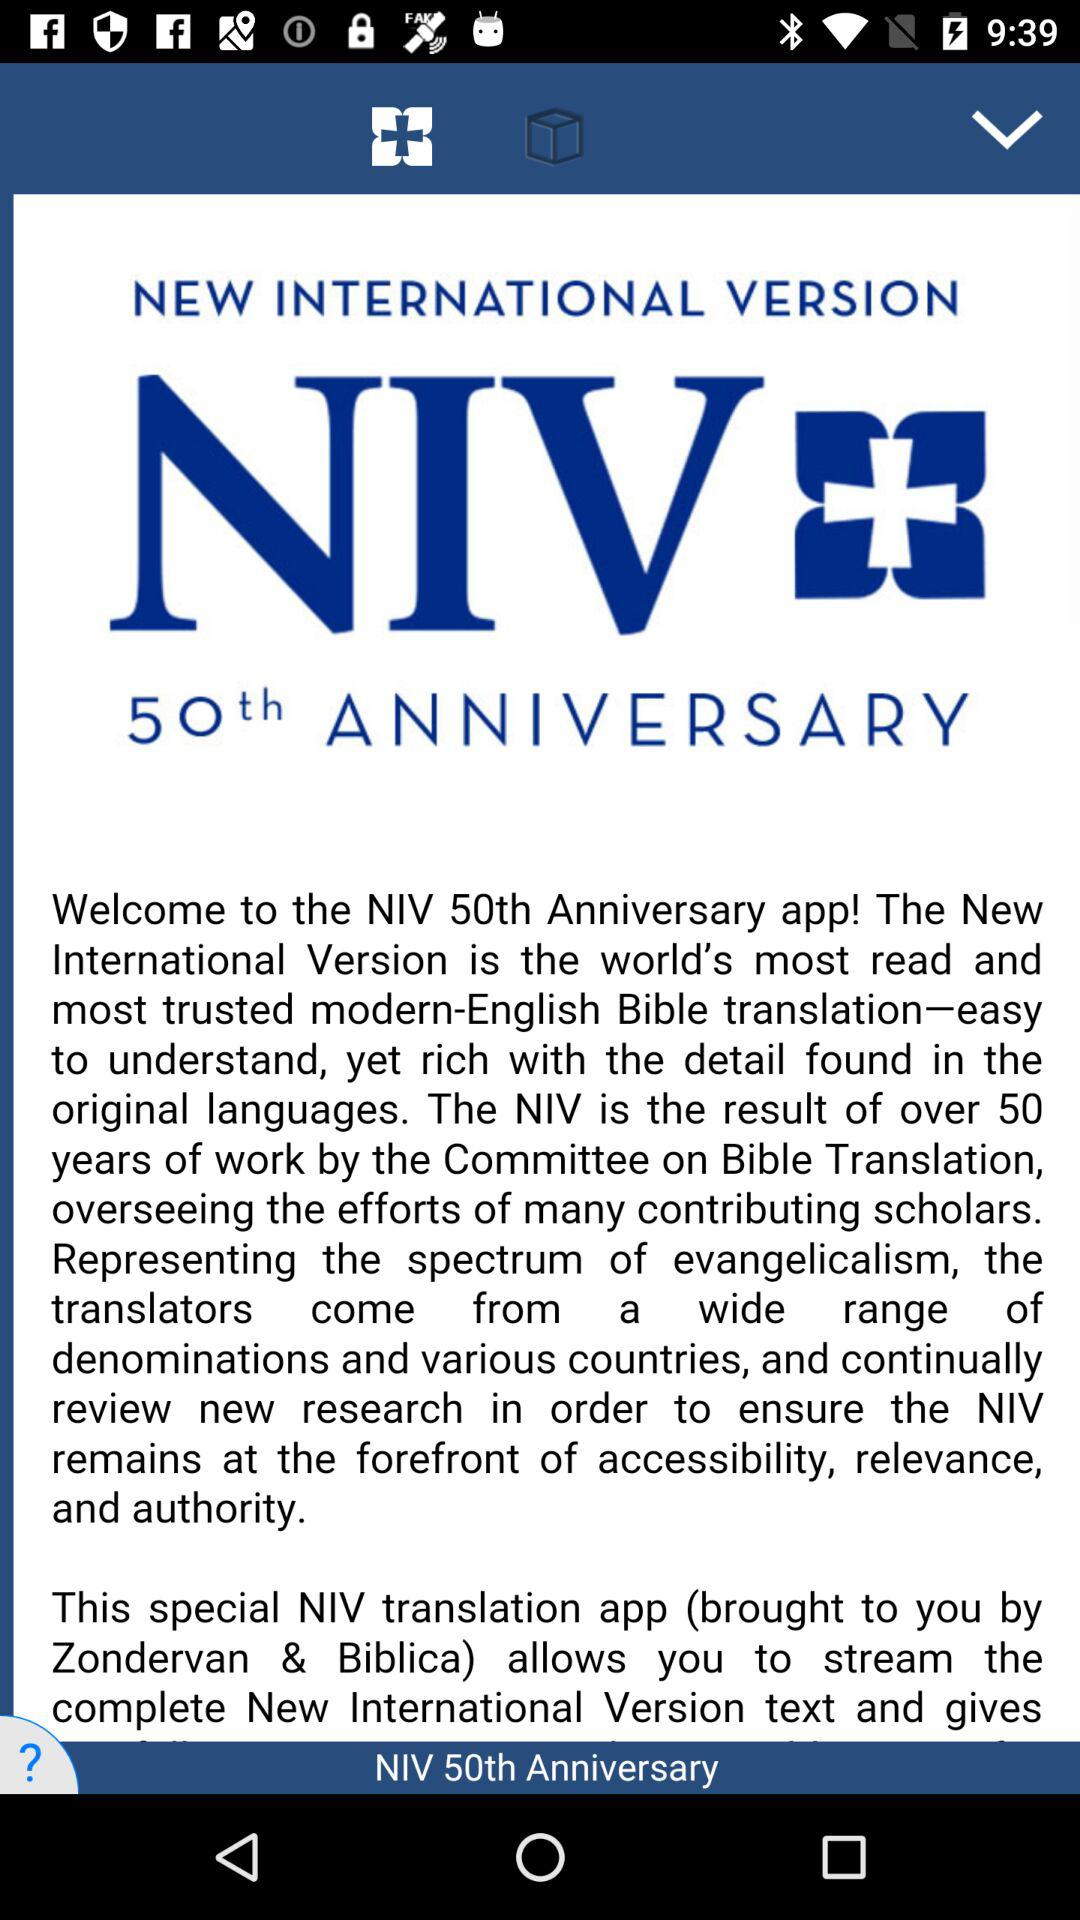Which anniversary is displayed on the screen? The anniversary displayed on the screen is the 50th. 